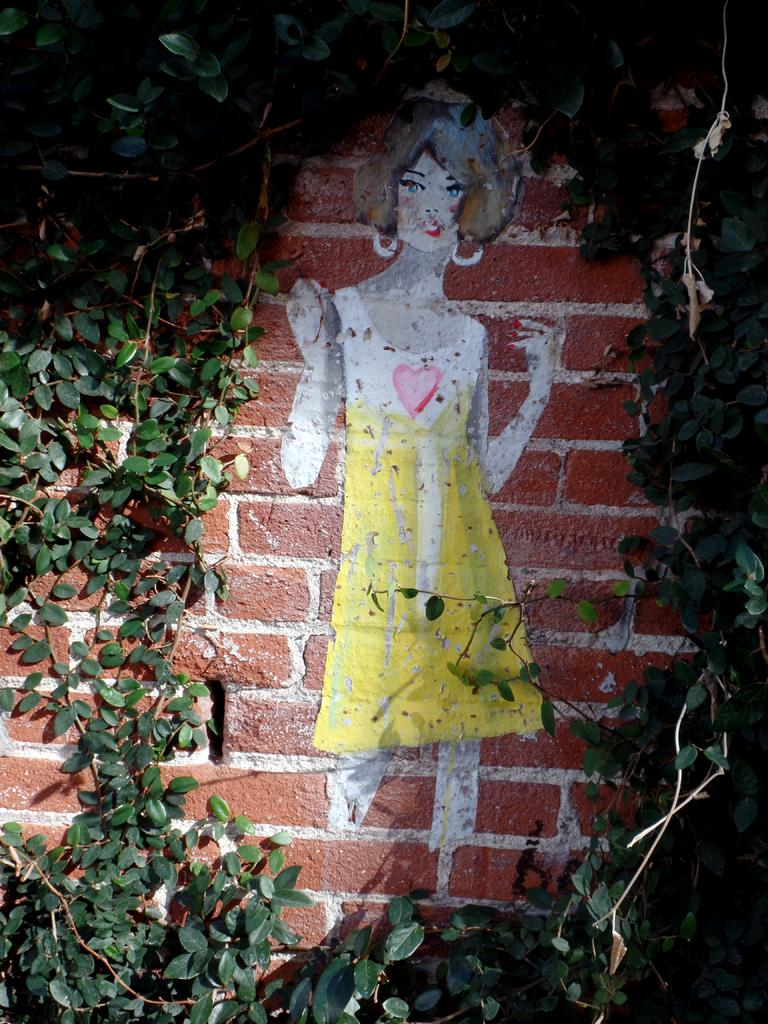What is hanging on the wall in the image? There is a painting on the wall in the image. What else can be seen in the image besides the painting? There are plants in the image. What type of lamp is hanging from the ceiling in the image? There is no lamp present in the image; it only features a painting and plants. 